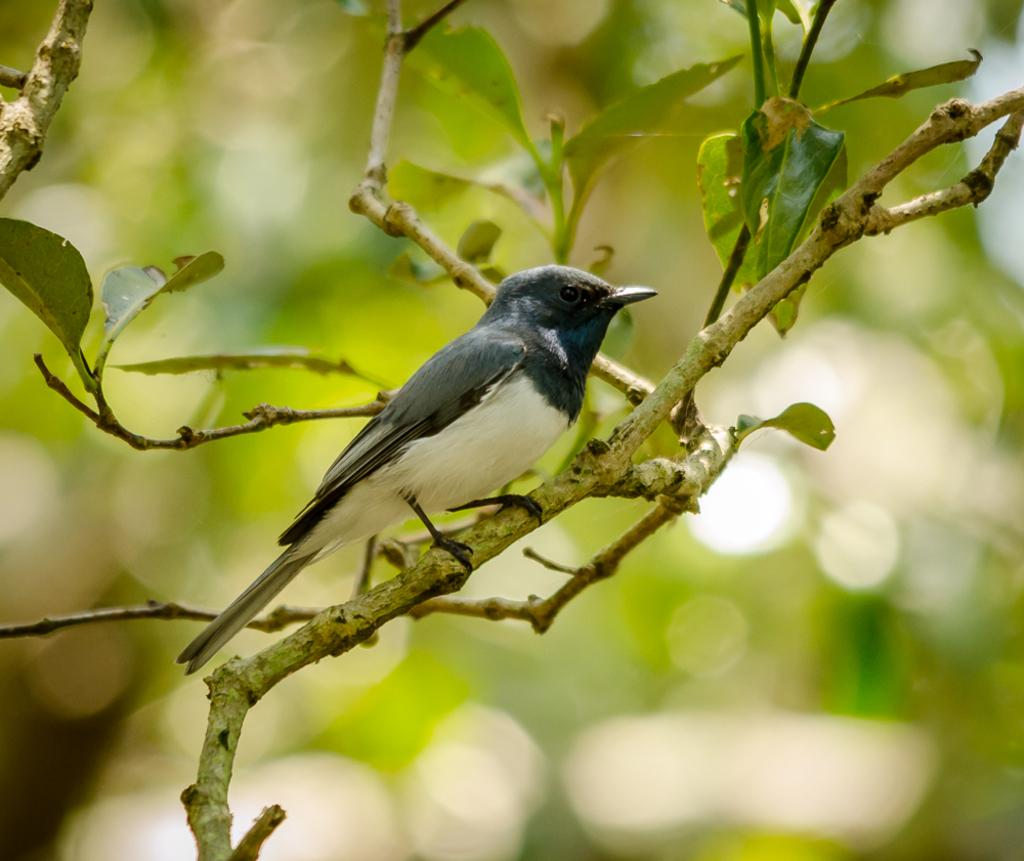What type of animal can be seen in the image? There is a bird in the image. Where is the bird located in the image? The bird is sitting on a branch. What is the branch a part of? The branch is part of a tree. What type of bulb is the bird using to light up the area in the image? There is no bulb present in the image, and the bird is not using any light source. 